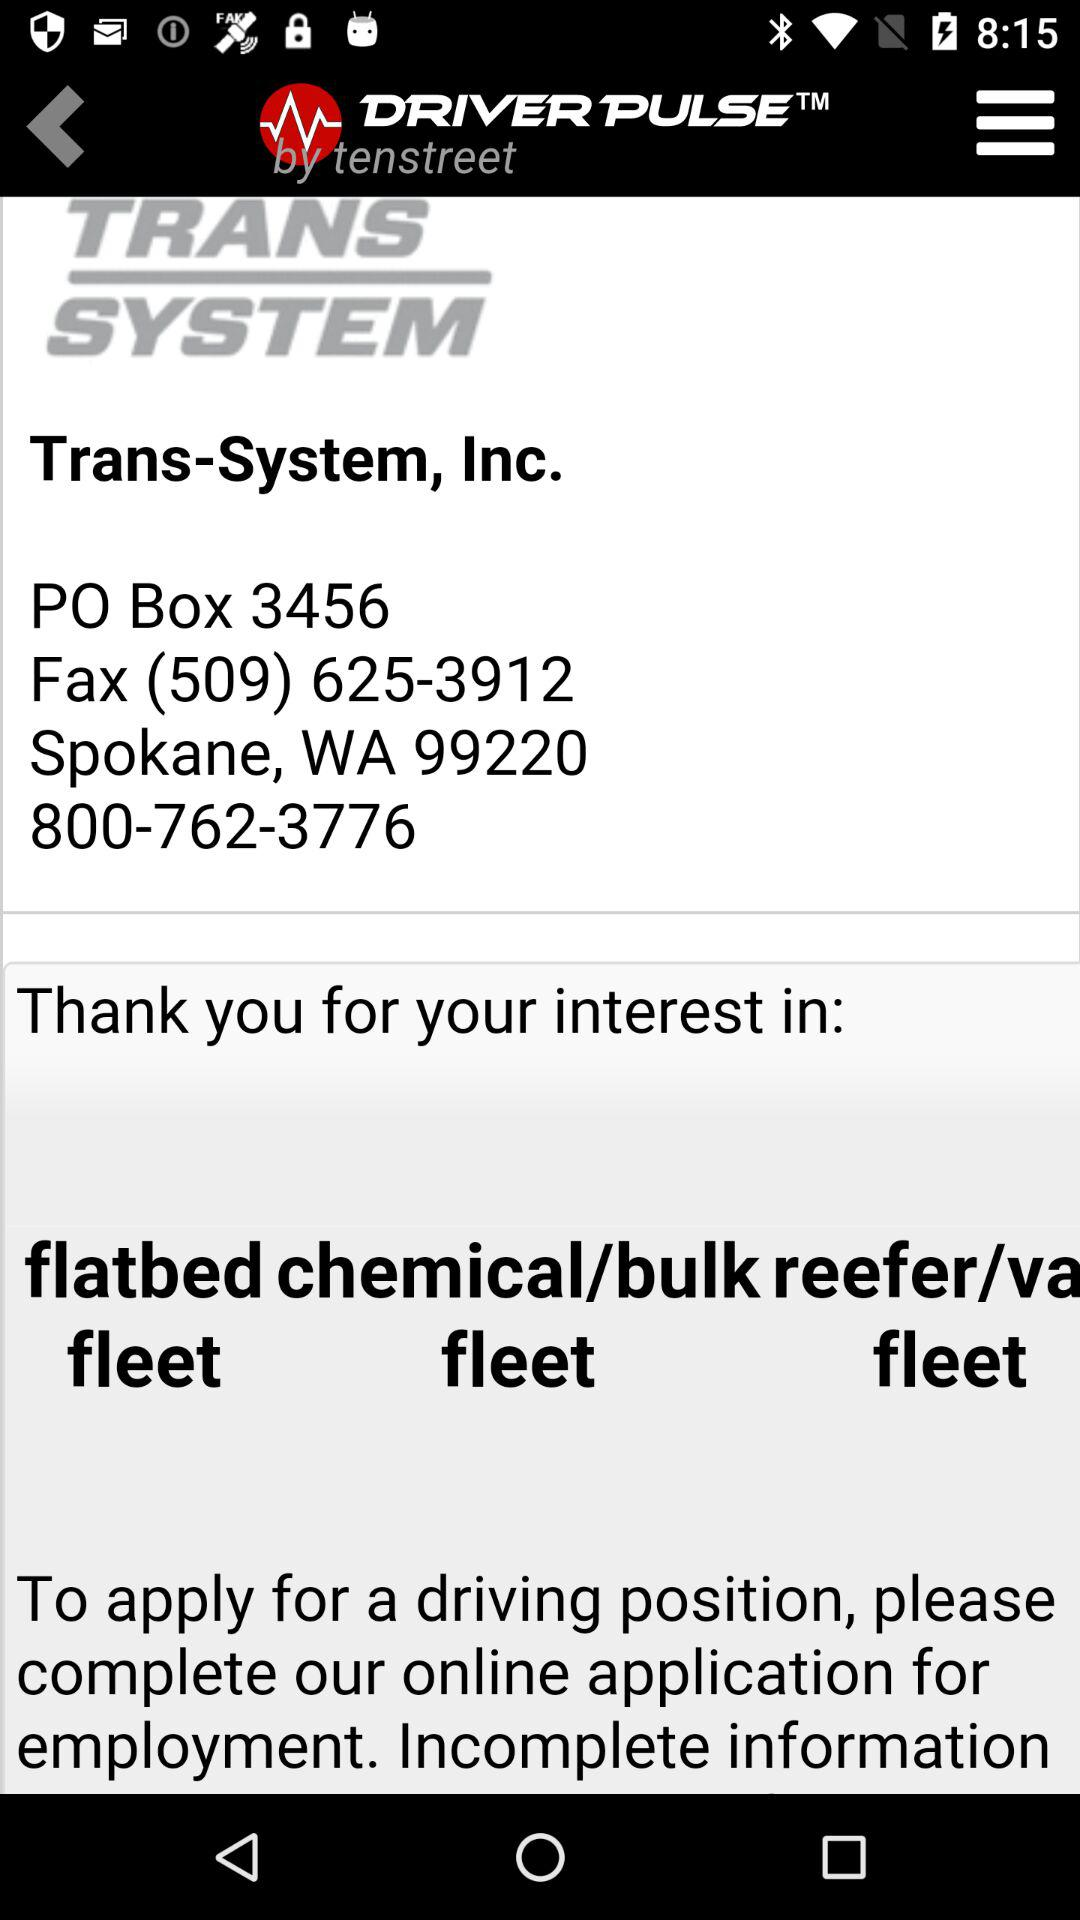Is the information complete?
When the provided information is insufficient, respond with <no answer>. <no answer> 